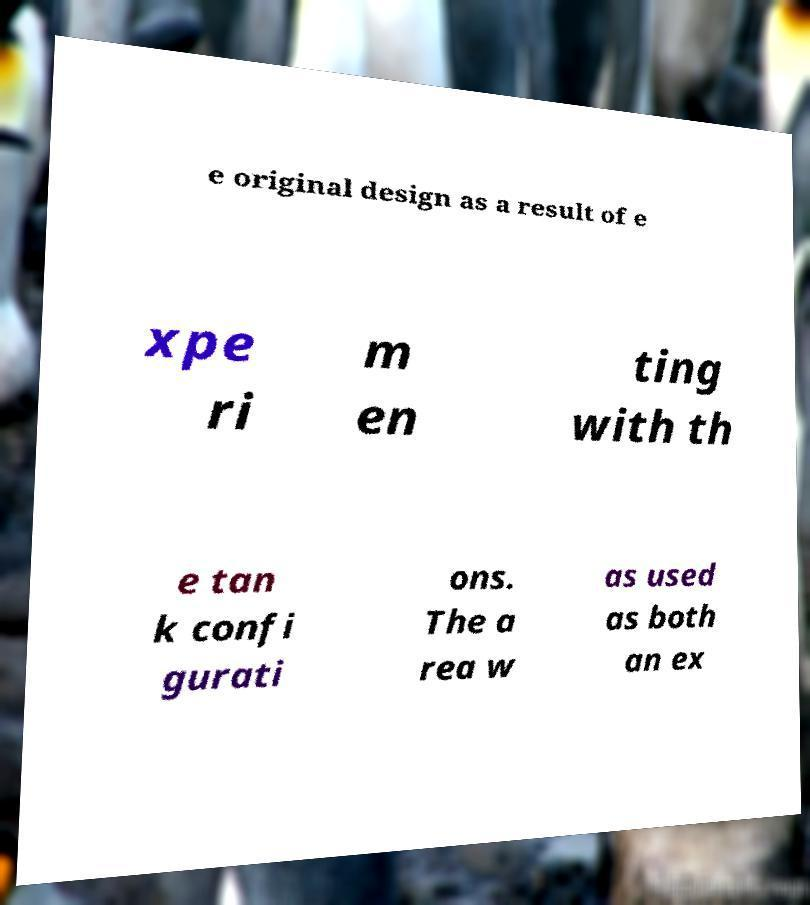Can you accurately transcribe the text from the provided image for me? e original design as a result of e xpe ri m en ting with th e tan k confi gurati ons. The a rea w as used as both an ex 